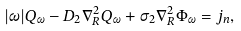Convert formula to latex. <formula><loc_0><loc_0><loc_500><loc_500>| \omega | Q _ { \omega } - D _ { 2 } \nabla ^ { 2 } _ { R } Q _ { \omega } + \sigma _ { 2 } \nabla _ { R } ^ { 2 } \Phi _ { \omega } = j _ { n } ,</formula> 